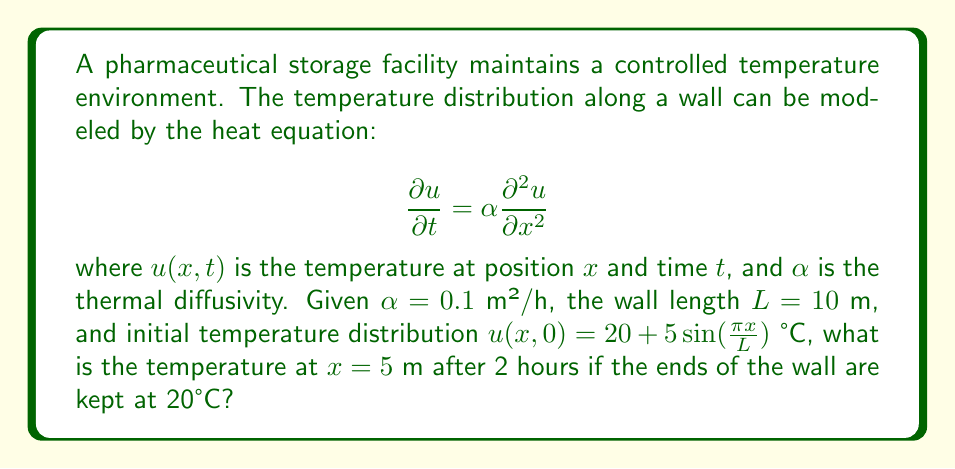Could you help me with this problem? To solve this problem, we'll use the method of separation of variables:

1) The general solution for the heat equation with the given boundary conditions is:

   $$u(x,t) = 20 + \sum_{n=1}^{\infty} B_n \sin(\frac{n\pi x}{L}) e^{-\alpha(\frac{n\pi}{L})^2t}$$

2) For the initial condition $u(x,0) = 20 + 5\sin(\frac{\pi x}{L})$, we can see that only the $n=1$ term is non-zero, with $B_1 = 5$.

3) Therefore, our solution simplifies to:

   $$u(x,t) = 20 + 5\sin(\frac{\pi x}{L}) e^{-\alpha(\frac{\pi}{L})^2t}$$

4) Now, we need to evaluate this at $x = 5$ m and $t = 2$ h:

   $$u(5,2) = 20 + 5\sin(\frac{\pi \cdot 5}{10}) e^{-0.1(\frac{\pi}{10})^2 \cdot 2}$$

5) Simplify:
   $$u(5,2) = 20 + 5\sin(\frac{\pi}{2}) e^{-0.1(\frac{\pi^2}{100}) \cdot 2}$$
   $$= 20 + 5 \cdot 1 \cdot e^{-0.002\pi^2}$$
   $$= 20 + 5e^{-0.002\pi^2}$$

6) Calculate the final value:
   $$u(5,2) \approx 20 + 5 \cdot 0.9802 = 24.901 \text{ °C}$$
Answer: 24.901 °C 